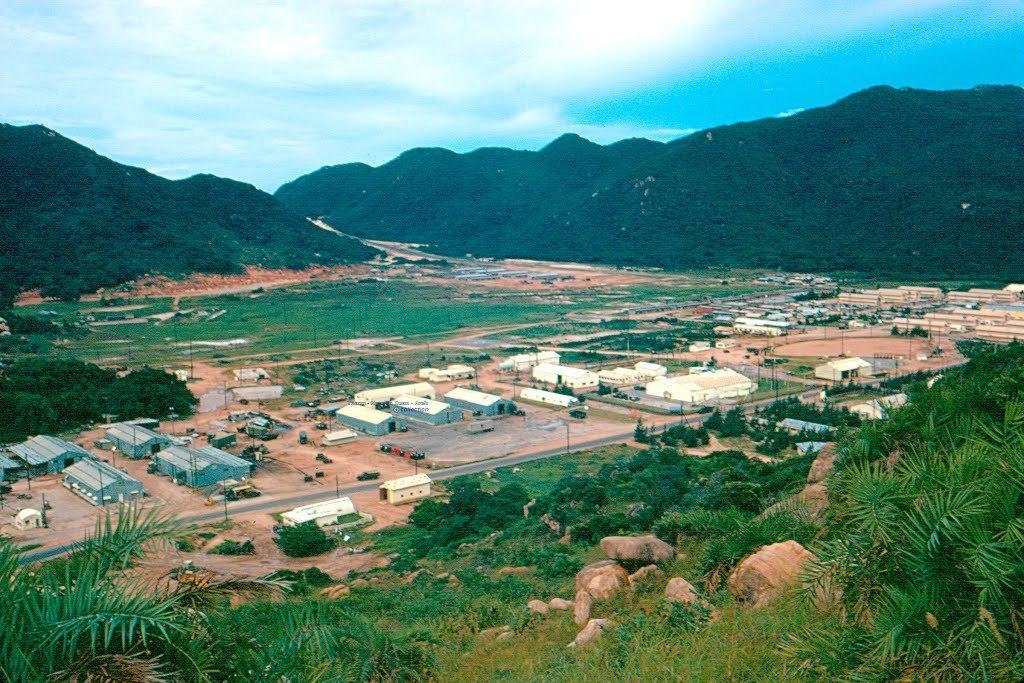Could you give a brief overview of what you see in this image? We can see grass,trees and stones. Here we can see houses. In the background we can see grass,trees,hills and sky. 